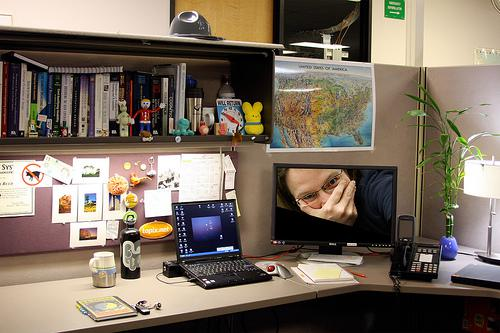Question: how many computers are on the desk?
Choices:
A. One.
B. Three.
C. Two.
D. Four.
Answer with the letter. Answer: C Question: what types of computers are visible?
Choices:
A. A laptop and desktop.
B. A tablet.
C. Broken ones.
D. New ones.
Answer with the letter. Answer: A Question: what is the screensaver on the desktop?
Choices:
A. A person's face.
B. Flowers.
C. Cats.
D. Cars.
Answer with the letter. Answer: A Question: where was this photo taken?
Choices:
A. In an office breakroom.
B. At a desk in a cubicle.
C. In an elevator.
D. In a building lobby.
Answer with the letter. Answer: B 